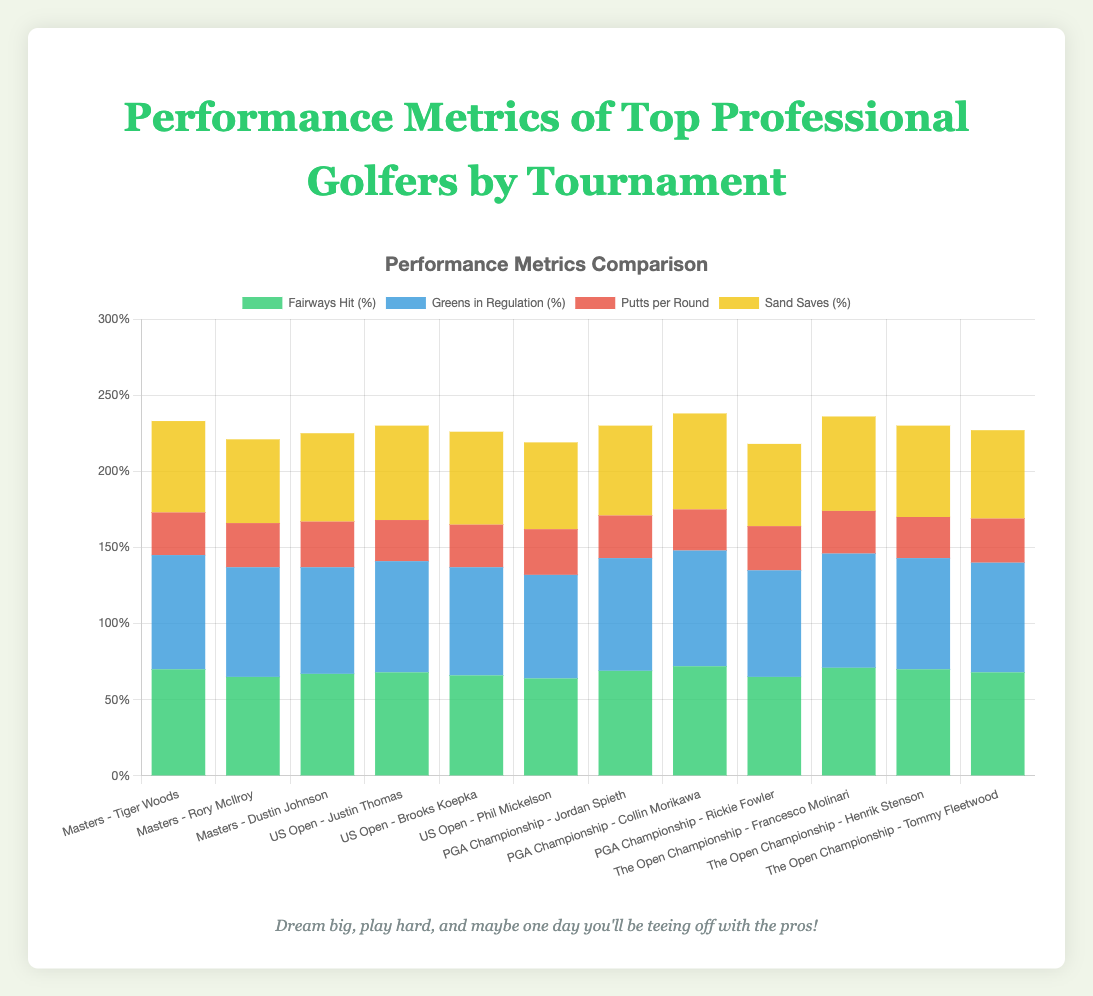What is the total percentage of Fairways Hit and Greens in Regulation for Tiger Woods in the Masters? To find the total percentage, sum the percentages of Fairways Hit and Greens in Regulation for Tiger Woods. Fairways Hit: 70%, Greens in Regulation: 75%. Thus, 70% + 75% = 145%
Answer: 145% Which golfer has the highest percentage of Greens in Regulation? Look at the Greens in Regulation percentages for all golfers and identify the highest one. Collin Morikawa has the highest percentage with 76%
Answer: Collin Morikawa Which golfer scored the lowest Putts per Round in the US Open? Check the Putts per Round values for all golfers in the US Open. The lowest Putts per Round is 27, achieved by Justin Thomas
Answer: Justin Thomas Compare the Sand Saves percentages between Henrik Stenson and Tommy Fleetwood in The Open Championship. Who performed better? Compare the Sand Saves percentages of Henrik Stenson (60%) and Tommy Fleetwood (58%). Henrik Stenson performed better, as 60% is higher than 58%
Answer: Henrik Stenson What's the combined average of Putts per Round for golfers in the PGA Championship? Calculate the combined average Putts per Round for Jordan Spieth (28), Collin Morikawa (27), and Rickie Fowler (29). Average = (28 + 27 + 29) / 3 = 84 / 3 = 28
Answer: 28 Which tournament has the highest average Fairways Hit percentage? Calculate the average Fairways Hit percentage for each tournament and compare them: 
- Masters: (70 + 65 + 67) / 3 = 202 / 3 ≈ 67.33
- US Open: (68 + 66 + 64) / 3 = 198 / 3 = 66
- PGA Championship: (69 + 72 + 65) / 3 = 206 / 3 ≈ 68.67
- The Open Championship: (71 + 70 + 68) / 3 = 209 / 3 ≈ 69.67
The highest average is in The Open Championship with ≈69.67%
Answer: The Open Championship In which metric does Francesco Molinari outperform Henrik Stenson in The Open Championship? Compare Francesco Molinari and Henrik Stenson for each metric in The Open Championship. Fairways Hit: 71% vs 70%, Greens in Regulation: 75% vs 73%, Putts per Round: 28 vs 27, Sand Saves: 62% vs 60%. Molinari outperforms Stenson in Fairways Hit, Greens in Regulation, and Sand Saves.
Answer: Fairways Hit, Greens in Regulation, Sand Saves What is the average Sand Saves percentage for all golfers in the Masters tournament? Calculate the average Sand Saves percentage for Tiger Woods (60%), Rory McIlroy (55%), and Dustin Johnson (58%). Average = (60 + 55 + 58) / 3 ≈ 57.67%
Answer: 57.67% How does Jordan Spieth's Greens in Regulation percentage in the PGA Championship compare to Rory McIlroy's in the Masters? Compare the Greens in Regulation percentages: Jordan Spieth has 74% and Rory McIlroy has 72%. Jordan Spieth's percentage is higher.
Answer: Jordan Spieth's is higher 